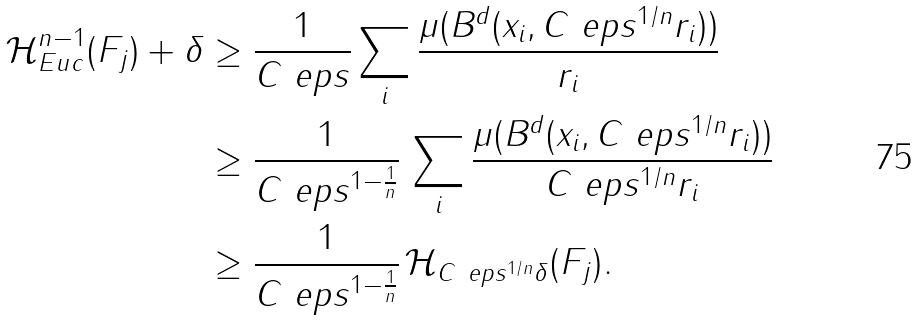<formula> <loc_0><loc_0><loc_500><loc_500>\mathcal { H } ^ { n - 1 } _ { E u c } ( F _ { j } ) + \delta & \geq \frac { 1 } { C \ e p s } \sum _ { i } \frac { \mu ( B ^ { d } ( x _ { i } , C \ e p s ^ { 1 / n } r _ { i } ) ) } { r _ { i } } \\ & \geq \frac { 1 } { C \ e p s ^ { 1 - \frac { 1 } { n } } } \, \sum _ { i } \frac { \mu ( B ^ { d } ( x _ { i } , C \ e p s ^ { 1 / n } r _ { i } ) ) } { C \ e p s ^ { 1 / n } r _ { i } } \\ & \geq \frac { 1 } { C \ e p s ^ { 1 - \frac { 1 } { n } } } \, \mathcal { H } _ { C \ e p s ^ { 1 / n } \delta } ( F _ { j } ) .</formula> 